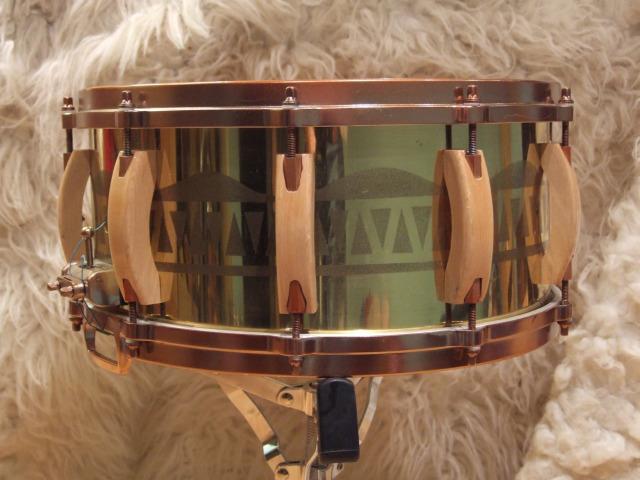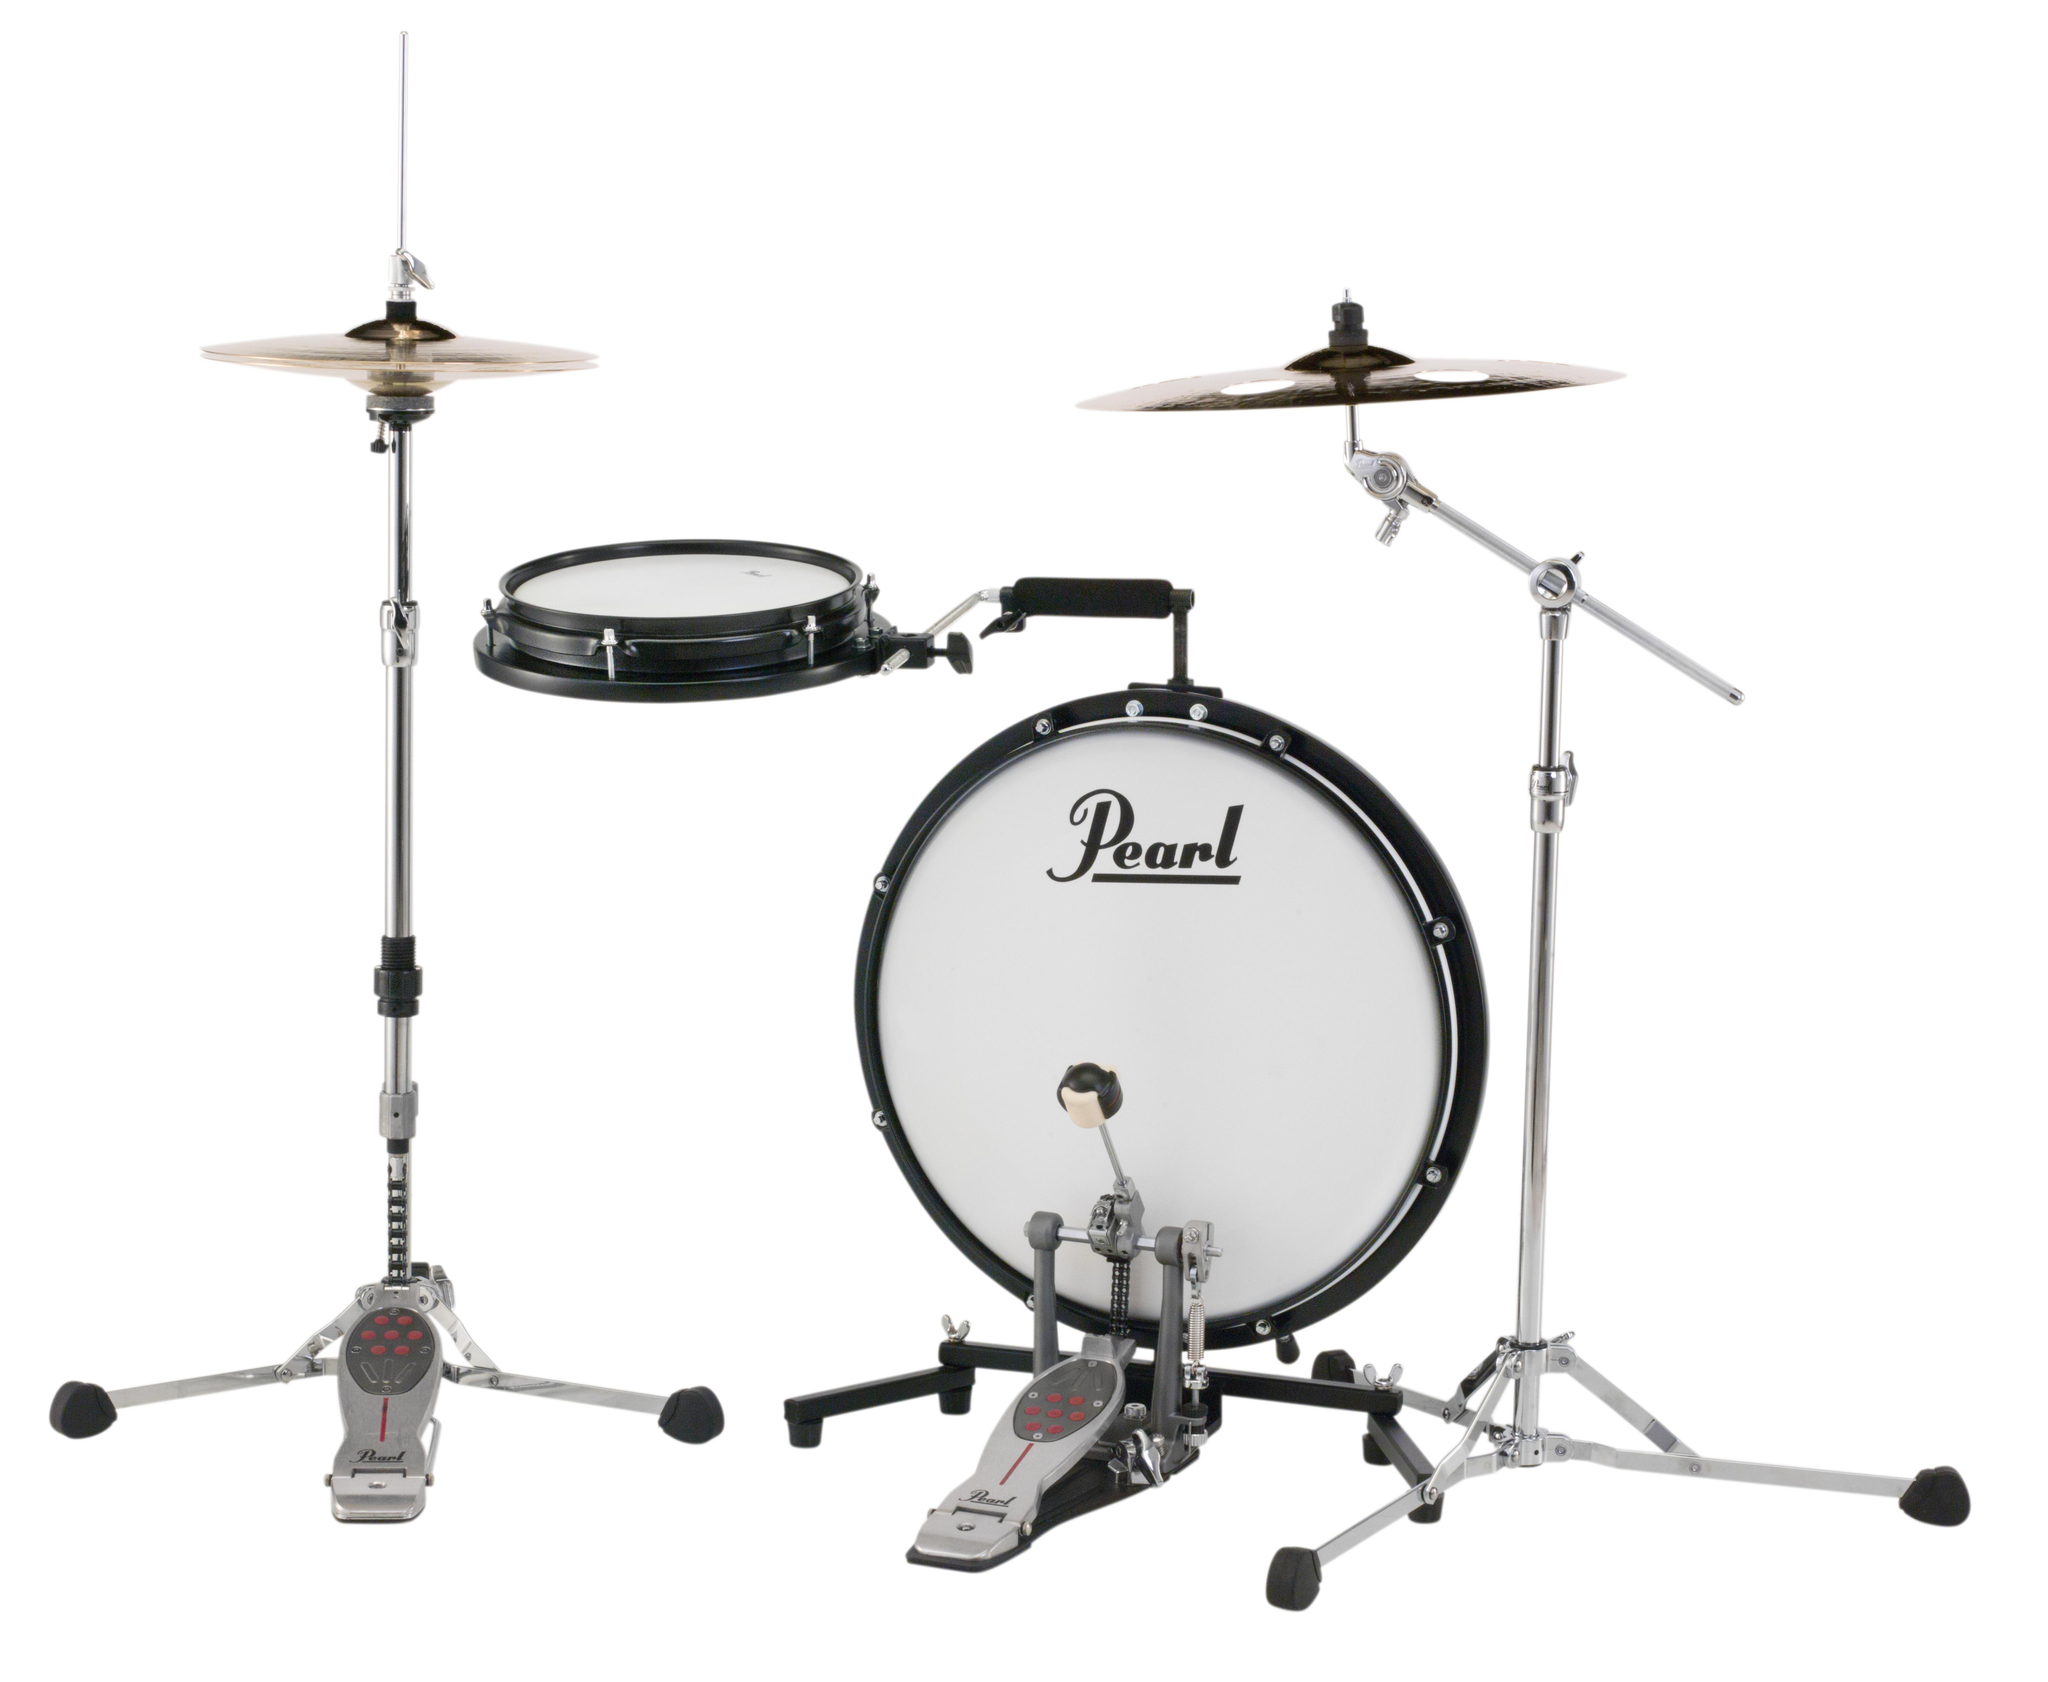The first image is the image on the left, the second image is the image on the right. Considering the images on both sides, is "Each image shows a connected pair of drums, and one image features wood grain drums without a footed stand." valid? Answer yes or no. No. The first image is the image on the left, the second image is the image on the right. Examine the images to the left and right. Is the description "There are exactly two pairs of bongo drums." accurate? Answer yes or no. No. 